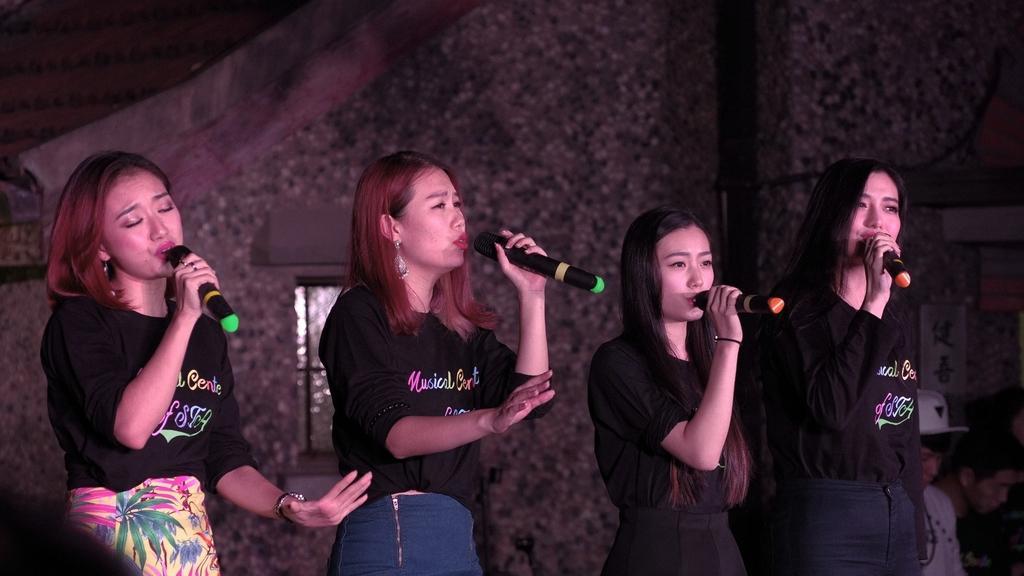How would you summarize this image in a sentence or two? Four women are singing with mics in their hands. 